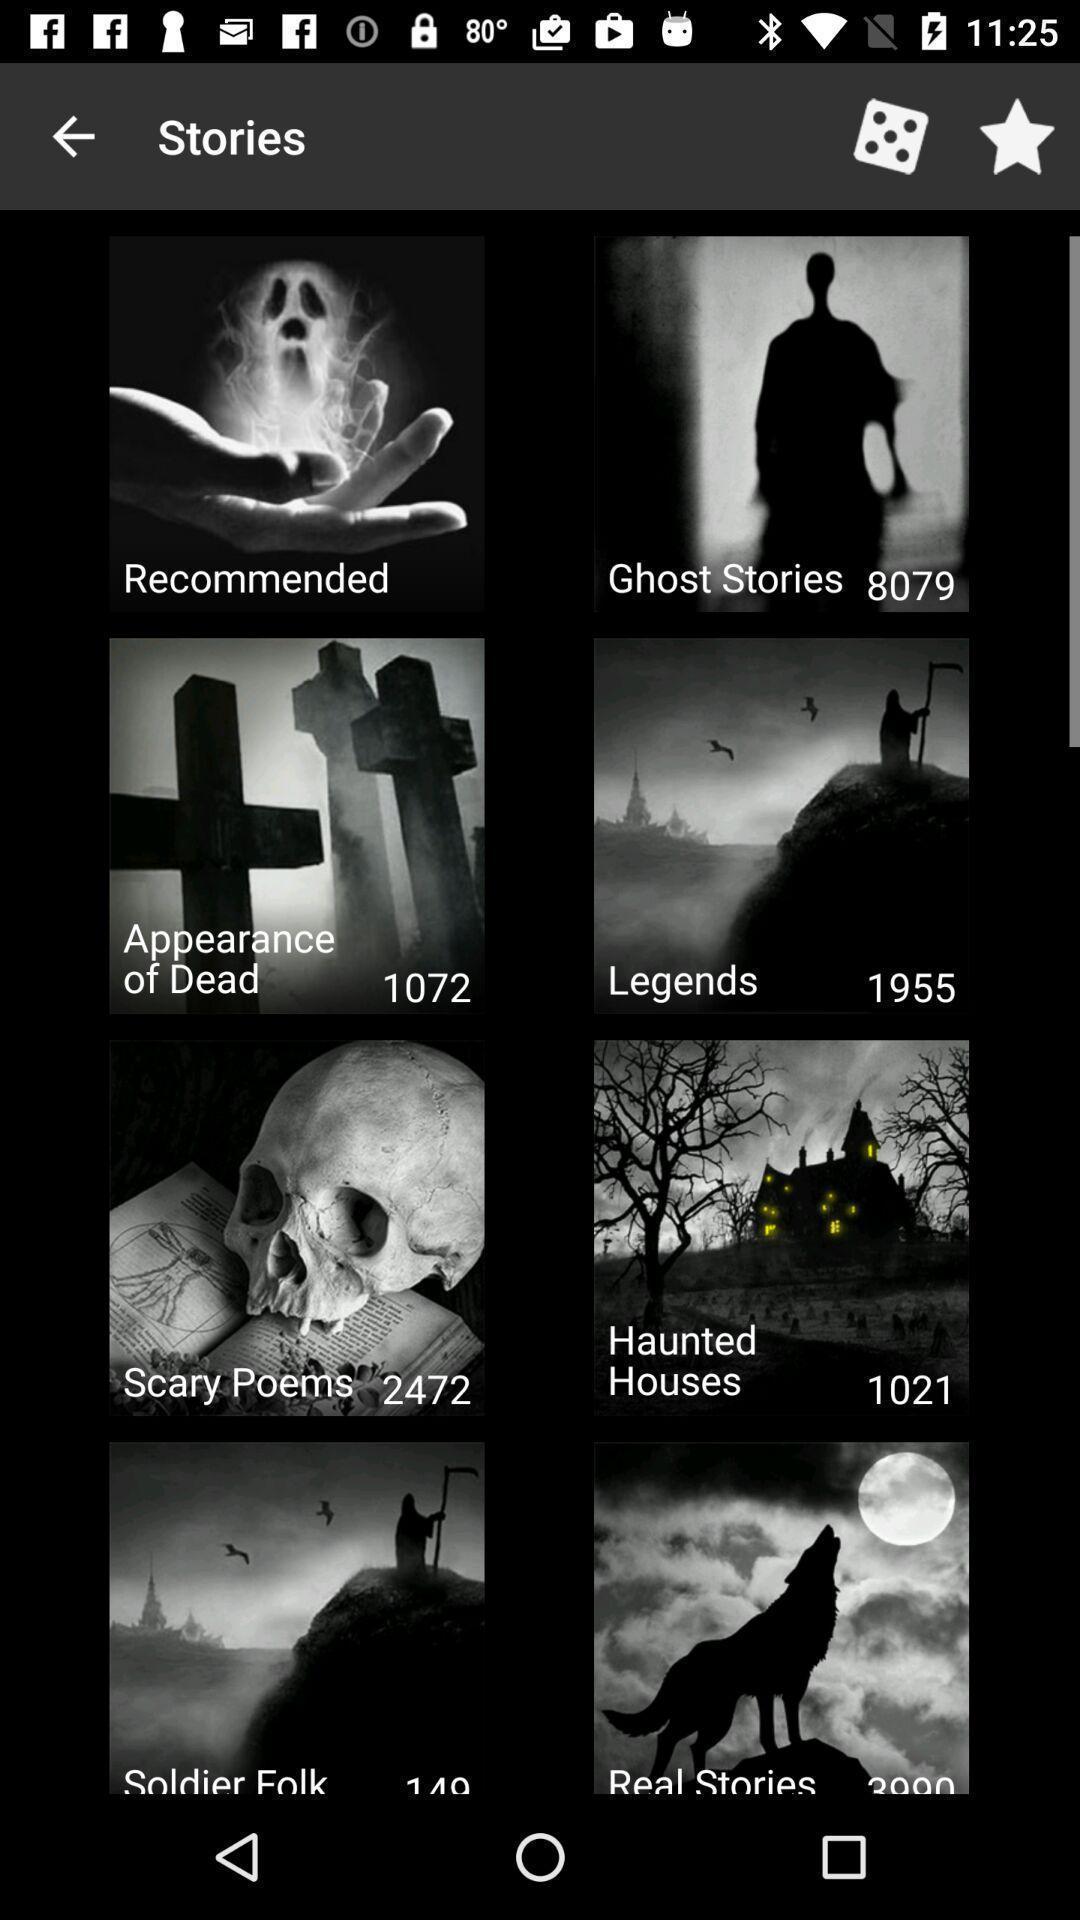Tell me what you see in this picture. Screen displaying multiple story category names. 